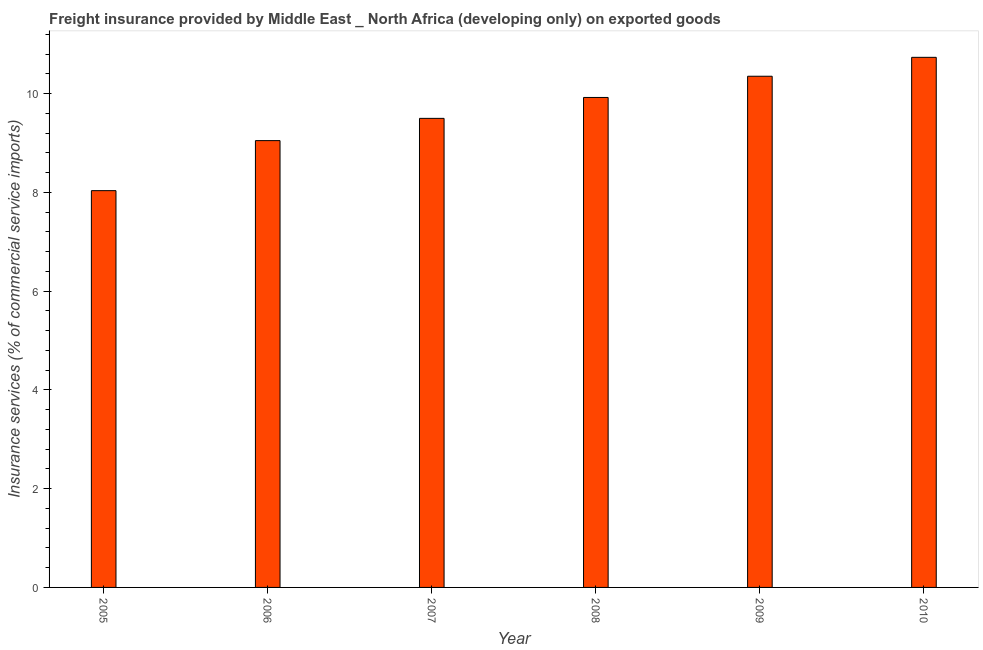Does the graph contain grids?
Your answer should be very brief. No. What is the title of the graph?
Provide a short and direct response. Freight insurance provided by Middle East _ North Africa (developing only) on exported goods . What is the label or title of the X-axis?
Offer a terse response. Year. What is the label or title of the Y-axis?
Your answer should be very brief. Insurance services (% of commercial service imports). What is the freight insurance in 2006?
Make the answer very short. 9.05. Across all years, what is the maximum freight insurance?
Keep it short and to the point. 10.74. Across all years, what is the minimum freight insurance?
Ensure brevity in your answer.  8.04. What is the sum of the freight insurance?
Provide a succinct answer. 57.6. What is the difference between the freight insurance in 2006 and 2008?
Offer a very short reply. -0.87. What is the average freight insurance per year?
Your answer should be very brief. 9.6. What is the median freight insurance?
Your response must be concise. 9.71. In how many years, is the freight insurance greater than 7.2 %?
Provide a succinct answer. 6. Do a majority of the years between 2009 and 2005 (inclusive) have freight insurance greater than 0.8 %?
Offer a very short reply. Yes. What is the ratio of the freight insurance in 2005 to that in 2009?
Ensure brevity in your answer.  0.78. What is the difference between the highest and the second highest freight insurance?
Provide a succinct answer. 0.38. In how many years, is the freight insurance greater than the average freight insurance taken over all years?
Keep it short and to the point. 3. Are all the bars in the graph horizontal?
Make the answer very short. No. What is the difference between two consecutive major ticks on the Y-axis?
Offer a terse response. 2. What is the Insurance services (% of commercial service imports) of 2005?
Your answer should be compact. 8.04. What is the Insurance services (% of commercial service imports) in 2006?
Your answer should be very brief. 9.05. What is the Insurance services (% of commercial service imports) in 2007?
Give a very brief answer. 9.5. What is the Insurance services (% of commercial service imports) of 2008?
Ensure brevity in your answer.  9.92. What is the Insurance services (% of commercial service imports) in 2009?
Provide a succinct answer. 10.35. What is the Insurance services (% of commercial service imports) of 2010?
Offer a terse response. 10.74. What is the difference between the Insurance services (% of commercial service imports) in 2005 and 2006?
Ensure brevity in your answer.  -1.01. What is the difference between the Insurance services (% of commercial service imports) in 2005 and 2007?
Your answer should be compact. -1.46. What is the difference between the Insurance services (% of commercial service imports) in 2005 and 2008?
Your answer should be very brief. -1.89. What is the difference between the Insurance services (% of commercial service imports) in 2005 and 2009?
Provide a short and direct response. -2.32. What is the difference between the Insurance services (% of commercial service imports) in 2005 and 2010?
Provide a short and direct response. -2.7. What is the difference between the Insurance services (% of commercial service imports) in 2006 and 2007?
Ensure brevity in your answer.  -0.45. What is the difference between the Insurance services (% of commercial service imports) in 2006 and 2008?
Your answer should be very brief. -0.87. What is the difference between the Insurance services (% of commercial service imports) in 2006 and 2009?
Offer a very short reply. -1.3. What is the difference between the Insurance services (% of commercial service imports) in 2006 and 2010?
Give a very brief answer. -1.69. What is the difference between the Insurance services (% of commercial service imports) in 2007 and 2008?
Your answer should be very brief. -0.42. What is the difference between the Insurance services (% of commercial service imports) in 2007 and 2009?
Provide a short and direct response. -0.85. What is the difference between the Insurance services (% of commercial service imports) in 2007 and 2010?
Provide a succinct answer. -1.24. What is the difference between the Insurance services (% of commercial service imports) in 2008 and 2009?
Your answer should be very brief. -0.43. What is the difference between the Insurance services (% of commercial service imports) in 2008 and 2010?
Your response must be concise. -0.81. What is the difference between the Insurance services (% of commercial service imports) in 2009 and 2010?
Make the answer very short. -0.38. What is the ratio of the Insurance services (% of commercial service imports) in 2005 to that in 2006?
Provide a short and direct response. 0.89. What is the ratio of the Insurance services (% of commercial service imports) in 2005 to that in 2007?
Give a very brief answer. 0.85. What is the ratio of the Insurance services (% of commercial service imports) in 2005 to that in 2008?
Give a very brief answer. 0.81. What is the ratio of the Insurance services (% of commercial service imports) in 2005 to that in 2009?
Offer a very short reply. 0.78. What is the ratio of the Insurance services (% of commercial service imports) in 2005 to that in 2010?
Keep it short and to the point. 0.75. What is the ratio of the Insurance services (% of commercial service imports) in 2006 to that in 2007?
Your response must be concise. 0.95. What is the ratio of the Insurance services (% of commercial service imports) in 2006 to that in 2008?
Your answer should be compact. 0.91. What is the ratio of the Insurance services (% of commercial service imports) in 2006 to that in 2009?
Ensure brevity in your answer.  0.87. What is the ratio of the Insurance services (% of commercial service imports) in 2006 to that in 2010?
Provide a short and direct response. 0.84. What is the ratio of the Insurance services (% of commercial service imports) in 2007 to that in 2008?
Make the answer very short. 0.96. What is the ratio of the Insurance services (% of commercial service imports) in 2007 to that in 2009?
Offer a terse response. 0.92. What is the ratio of the Insurance services (% of commercial service imports) in 2007 to that in 2010?
Give a very brief answer. 0.89. What is the ratio of the Insurance services (% of commercial service imports) in 2008 to that in 2010?
Make the answer very short. 0.92. 